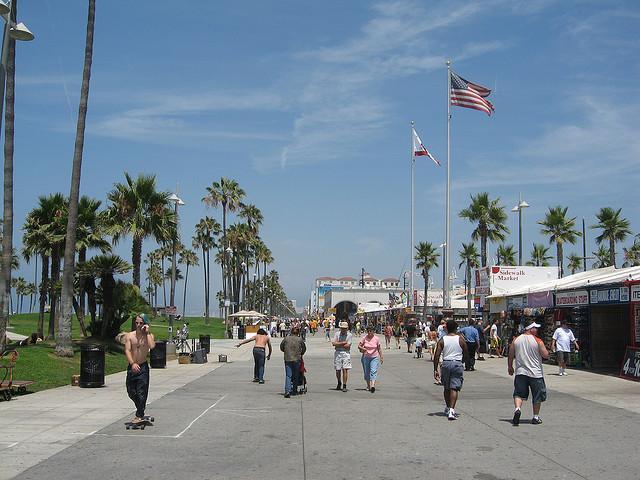How many flags are there?
Give a very brief answer. 2. How many kids are skating?
Give a very brief answer. 2. How many skateboards are visible?
Give a very brief answer. 1. How many people are there?
Give a very brief answer. 3. How many cats are there?
Give a very brief answer. 0. 